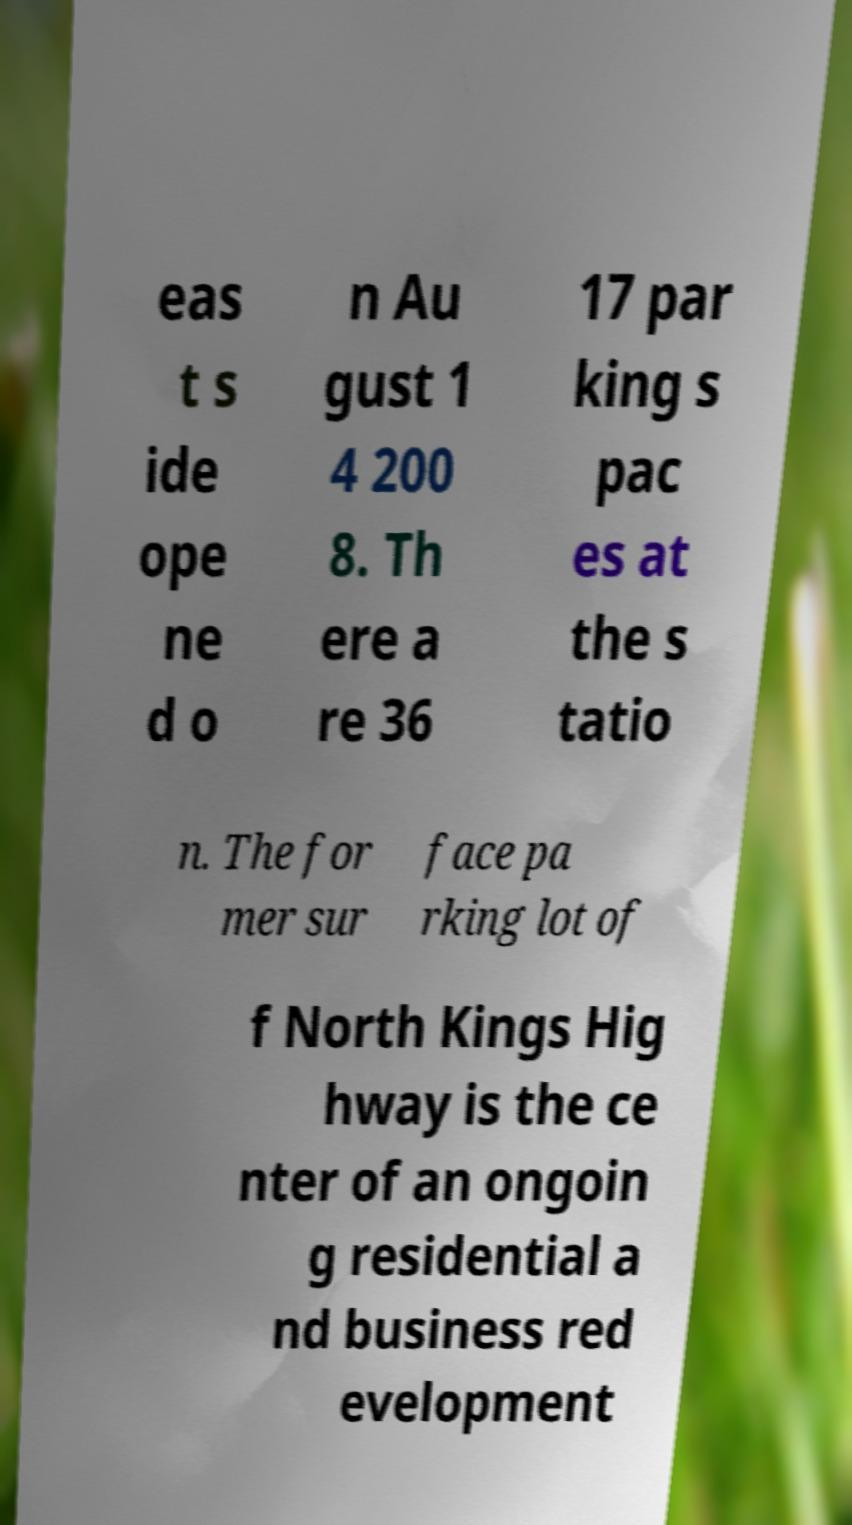Please read and relay the text visible in this image. What does it say? eas t s ide ope ne d o n Au gust 1 4 200 8. Th ere a re 36 17 par king s pac es at the s tatio n. The for mer sur face pa rking lot of f North Kings Hig hway is the ce nter of an ongoin g residential a nd business red evelopment 